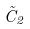Convert formula to latex. <formula><loc_0><loc_0><loc_500><loc_500>\tilde { C } _ { 2 }</formula> 